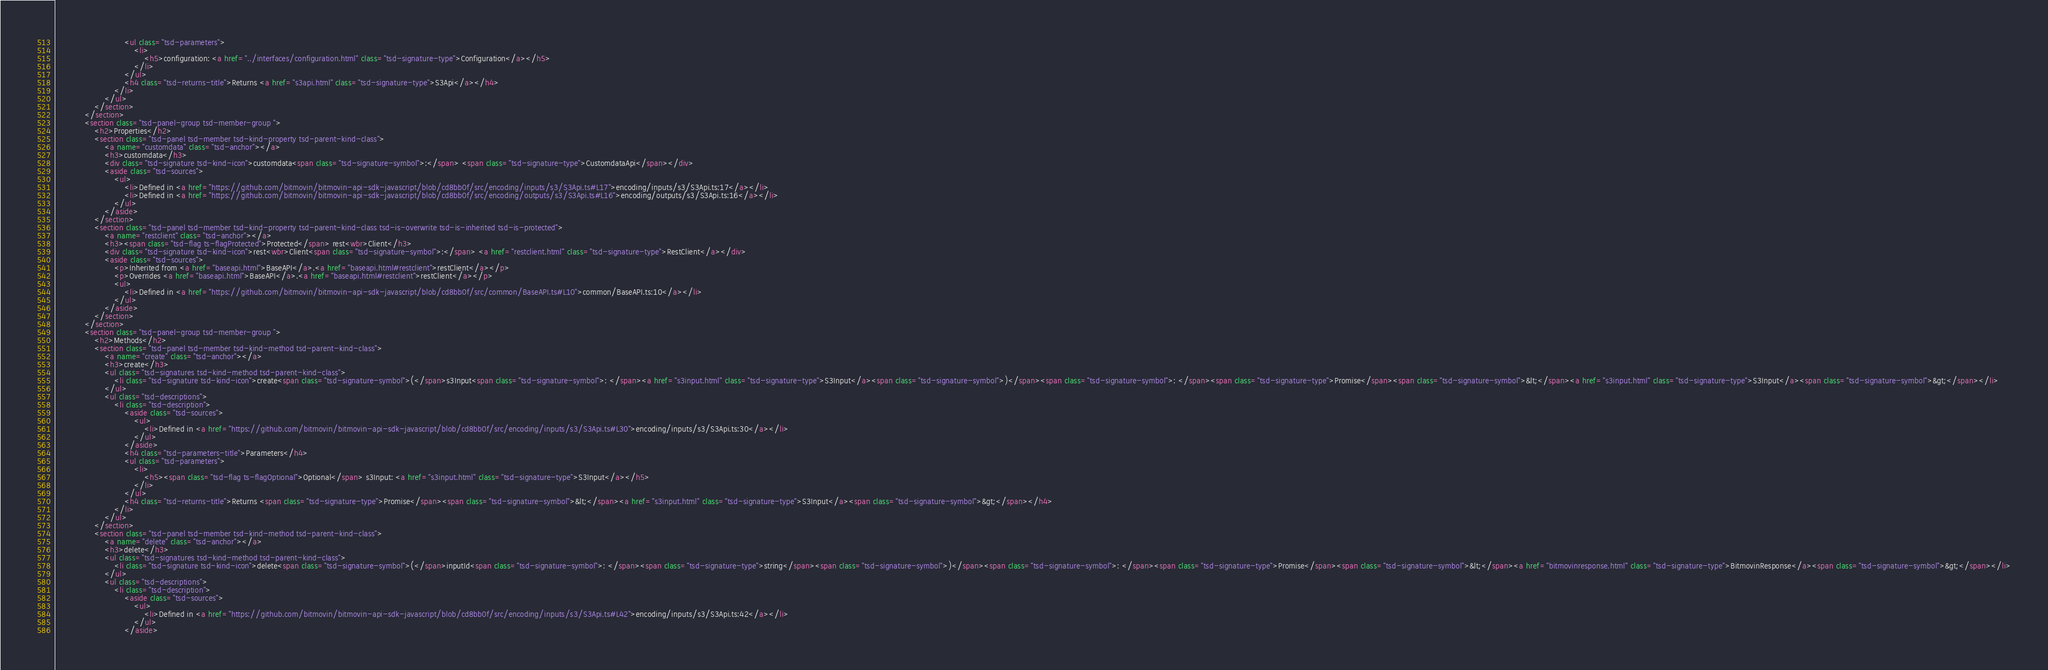Convert code to text. <code><loc_0><loc_0><loc_500><loc_500><_HTML_>							<ul class="tsd-parameters">
								<li>
									<h5>configuration: <a href="../interfaces/configuration.html" class="tsd-signature-type">Configuration</a></h5>
								</li>
							</ul>
							<h4 class="tsd-returns-title">Returns <a href="s3api.html" class="tsd-signature-type">S3Api</a></h4>
						</li>
					</ul>
				</section>
			</section>
			<section class="tsd-panel-group tsd-member-group ">
				<h2>Properties</h2>
				<section class="tsd-panel tsd-member tsd-kind-property tsd-parent-kind-class">
					<a name="customdata" class="tsd-anchor"></a>
					<h3>customdata</h3>
					<div class="tsd-signature tsd-kind-icon">customdata<span class="tsd-signature-symbol">:</span> <span class="tsd-signature-type">CustomdataApi</span></div>
					<aside class="tsd-sources">
						<ul>
							<li>Defined in <a href="https://github.com/bitmovin/bitmovin-api-sdk-javascript/blob/cd8bb0f/src/encoding/inputs/s3/S3Api.ts#L17">encoding/inputs/s3/S3Api.ts:17</a></li>
							<li>Defined in <a href="https://github.com/bitmovin/bitmovin-api-sdk-javascript/blob/cd8bb0f/src/encoding/outputs/s3/S3Api.ts#L16">encoding/outputs/s3/S3Api.ts:16</a></li>
						</ul>
					</aside>
				</section>
				<section class="tsd-panel tsd-member tsd-kind-property tsd-parent-kind-class tsd-is-overwrite tsd-is-inherited tsd-is-protected">
					<a name="restclient" class="tsd-anchor"></a>
					<h3><span class="tsd-flag ts-flagProtected">Protected</span> rest<wbr>Client</h3>
					<div class="tsd-signature tsd-kind-icon">rest<wbr>Client<span class="tsd-signature-symbol">:</span> <a href="restclient.html" class="tsd-signature-type">RestClient</a></div>
					<aside class="tsd-sources">
						<p>Inherited from <a href="baseapi.html">BaseAPI</a>.<a href="baseapi.html#restclient">restClient</a></p>
						<p>Overrides <a href="baseapi.html">BaseAPI</a>.<a href="baseapi.html#restclient">restClient</a></p>
						<ul>
							<li>Defined in <a href="https://github.com/bitmovin/bitmovin-api-sdk-javascript/blob/cd8bb0f/src/common/BaseAPI.ts#L10">common/BaseAPI.ts:10</a></li>
						</ul>
					</aside>
				</section>
			</section>
			<section class="tsd-panel-group tsd-member-group ">
				<h2>Methods</h2>
				<section class="tsd-panel tsd-member tsd-kind-method tsd-parent-kind-class">
					<a name="create" class="tsd-anchor"></a>
					<h3>create</h3>
					<ul class="tsd-signatures tsd-kind-method tsd-parent-kind-class">
						<li class="tsd-signature tsd-kind-icon">create<span class="tsd-signature-symbol">(</span>s3Input<span class="tsd-signature-symbol">: </span><a href="s3input.html" class="tsd-signature-type">S3Input</a><span class="tsd-signature-symbol">)</span><span class="tsd-signature-symbol">: </span><span class="tsd-signature-type">Promise</span><span class="tsd-signature-symbol">&lt;</span><a href="s3input.html" class="tsd-signature-type">S3Input</a><span class="tsd-signature-symbol">&gt;</span></li>
					</ul>
					<ul class="tsd-descriptions">
						<li class="tsd-description">
							<aside class="tsd-sources">
								<ul>
									<li>Defined in <a href="https://github.com/bitmovin/bitmovin-api-sdk-javascript/blob/cd8bb0f/src/encoding/inputs/s3/S3Api.ts#L30">encoding/inputs/s3/S3Api.ts:30</a></li>
								</ul>
							</aside>
							<h4 class="tsd-parameters-title">Parameters</h4>
							<ul class="tsd-parameters">
								<li>
									<h5><span class="tsd-flag ts-flagOptional">Optional</span> s3Input: <a href="s3input.html" class="tsd-signature-type">S3Input</a></h5>
								</li>
							</ul>
							<h4 class="tsd-returns-title">Returns <span class="tsd-signature-type">Promise</span><span class="tsd-signature-symbol">&lt;</span><a href="s3input.html" class="tsd-signature-type">S3Input</a><span class="tsd-signature-symbol">&gt;</span></h4>
						</li>
					</ul>
				</section>
				<section class="tsd-panel tsd-member tsd-kind-method tsd-parent-kind-class">
					<a name="delete" class="tsd-anchor"></a>
					<h3>delete</h3>
					<ul class="tsd-signatures tsd-kind-method tsd-parent-kind-class">
						<li class="tsd-signature tsd-kind-icon">delete<span class="tsd-signature-symbol">(</span>inputId<span class="tsd-signature-symbol">: </span><span class="tsd-signature-type">string</span><span class="tsd-signature-symbol">)</span><span class="tsd-signature-symbol">: </span><span class="tsd-signature-type">Promise</span><span class="tsd-signature-symbol">&lt;</span><a href="bitmovinresponse.html" class="tsd-signature-type">BitmovinResponse</a><span class="tsd-signature-symbol">&gt;</span></li>
					</ul>
					<ul class="tsd-descriptions">
						<li class="tsd-description">
							<aside class="tsd-sources">
								<ul>
									<li>Defined in <a href="https://github.com/bitmovin/bitmovin-api-sdk-javascript/blob/cd8bb0f/src/encoding/inputs/s3/S3Api.ts#L42">encoding/inputs/s3/S3Api.ts:42</a></li>
								</ul>
							</aside></code> 